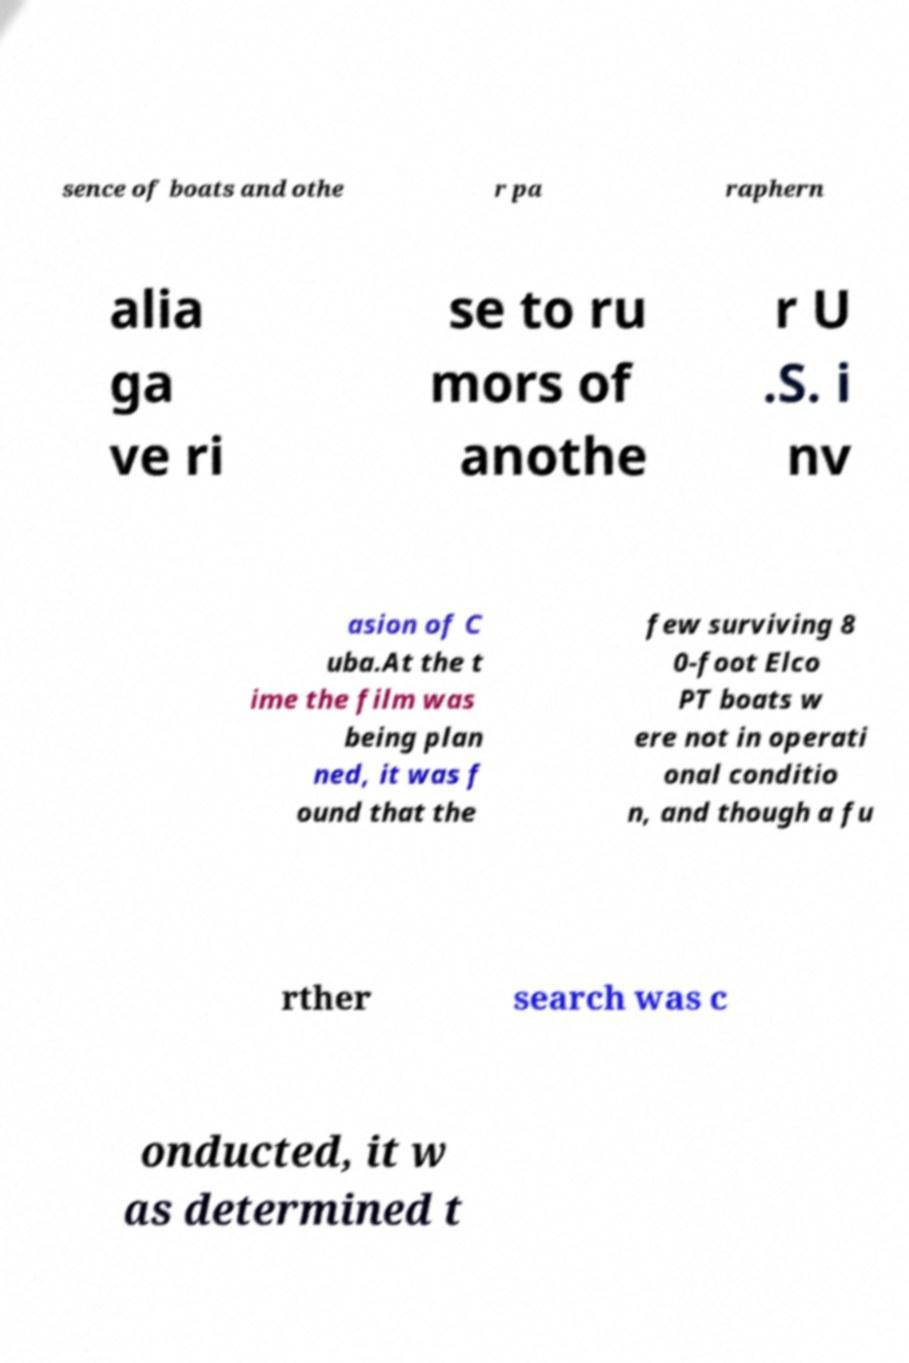Please identify and transcribe the text found in this image. sence of boats and othe r pa raphern alia ga ve ri se to ru mors of anothe r U .S. i nv asion of C uba.At the t ime the film was being plan ned, it was f ound that the few surviving 8 0-foot Elco PT boats w ere not in operati onal conditio n, and though a fu rther search was c onducted, it w as determined t 